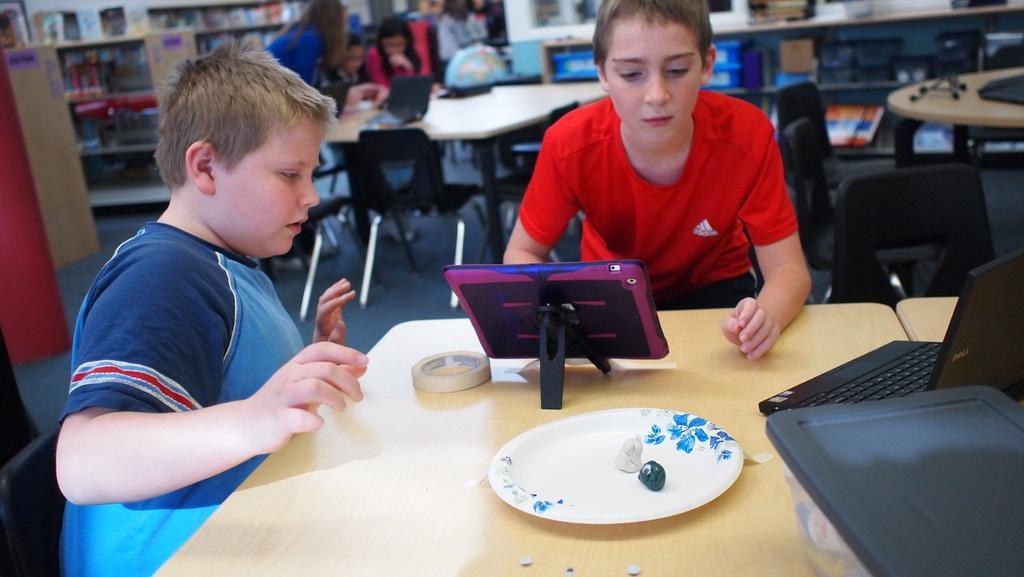In one or two sentences, can you explain what this image depicts? Here we can see a couple of children sitting on chairs with a table in front of them and the table is having it tablet, plaster and plate and laptop present on it behind them also we can see group of people and there are racks of books present 